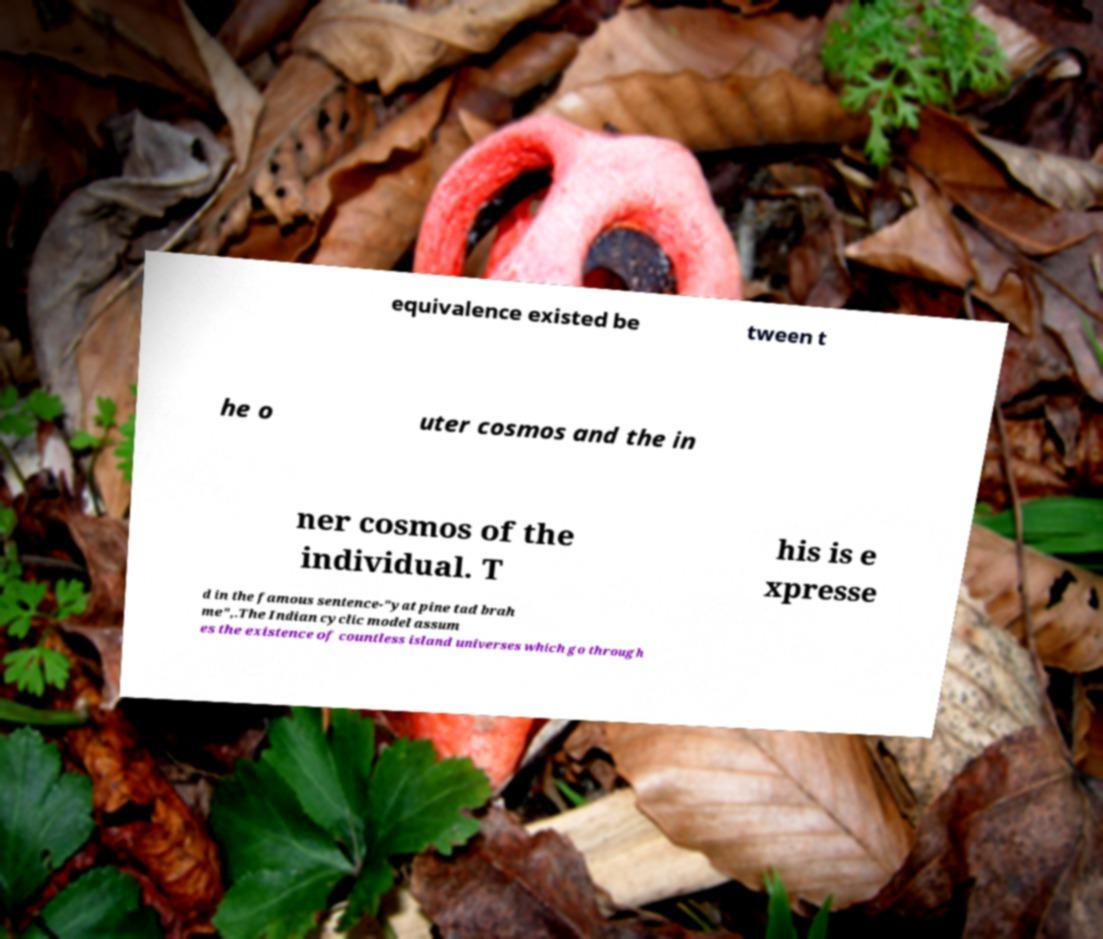What messages or text are displayed in this image? I need them in a readable, typed format. equivalence existed be tween t he o uter cosmos and the in ner cosmos of the individual. T his is e xpresse d in the famous sentence-"yat pine tad brah me",.The Indian cyclic model assum es the existence of countless island universes which go through 